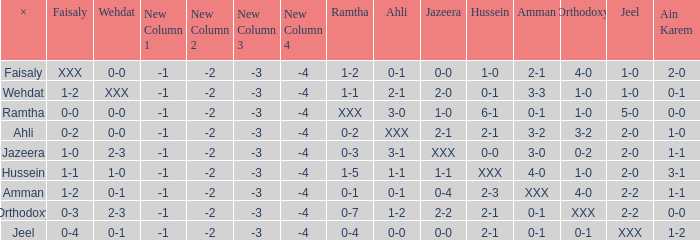What is ahli when ramtha is 0-4? 0-0. 